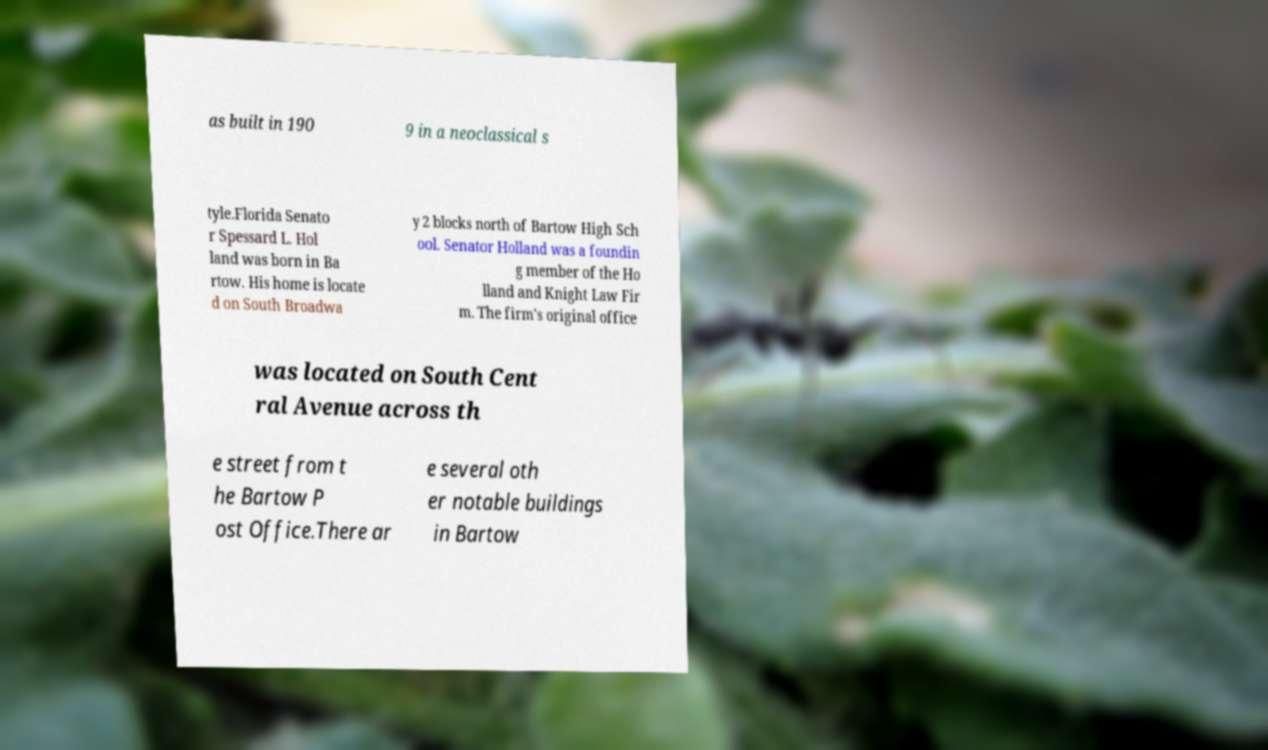For documentation purposes, I need the text within this image transcribed. Could you provide that? as built in 190 9 in a neoclassical s tyle.Florida Senato r Spessard L. Hol land was born in Ba rtow. His home is locate d on South Broadwa y 2 blocks north of Bartow High Sch ool. Senator Holland was a foundin g member of the Ho lland and Knight Law Fir m. The firm's original office was located on South Cent ral Avenue across th e street from t he Bartow P ost Office.There ar e several oth er notable buildings in Bartow 